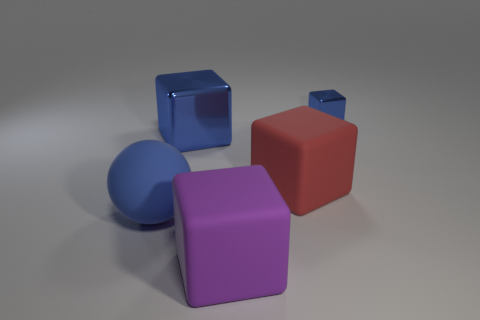Subtract all brown spheres. How many blue blocks are left? 2 Subtract all red blocks. How many blocks are left? 3 Subtract all large blue metal cubes. How many cubes are left? 3 Add 4 big purple cylinders. How many objects exist? 9 Subtract all cubes. How many objects are left? 1 Subtract all cyan blocks. Subtract all red spheres. How many blocks are left? 4 Add 2 small blue metal blocks. How many small blue metal blocks are left? 3 Add 5 blue objects. How many blue objects exist? 8 Subtract 0 green blocks. How many objects are left? 5 Subtract all small blue cylinders. Subtract all big red things. How many objects are left? 4 